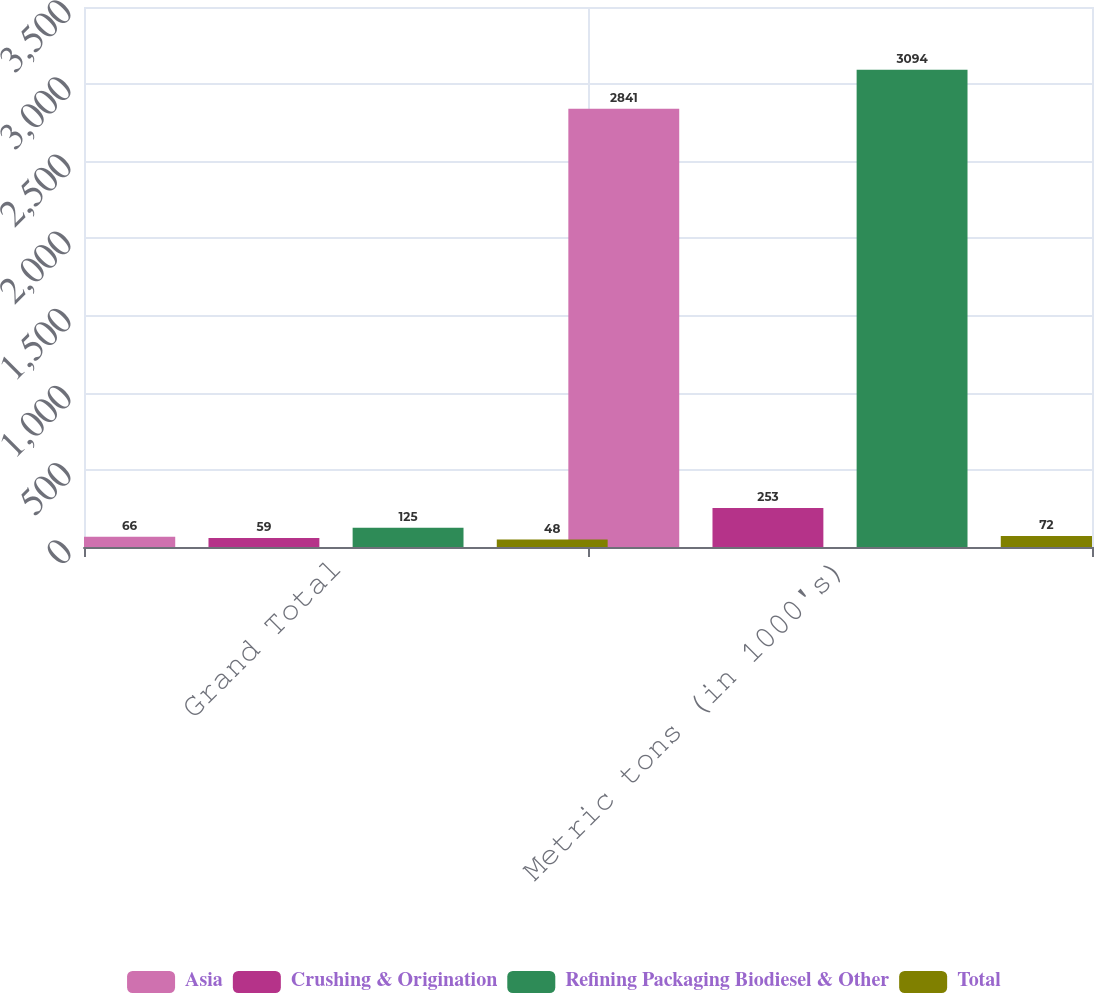Convert chart. <chart><loc_0><loc_0><loc_500><loc_500><stacked_bar_chart><ecel><fcel>Grand Total<fcel>Metric tons (in 1000's)<nl><fcel>Asia<fcel>66<fcel>2841<nl><fcel>Crushing & Origination<fcel>59<fcel>253<nl><fcel>Refining Packaging Biodiesel & Other<fcel>125<fcel>3094<nl><fcel>Total<fcel>48<fcel>72<nl></chart> 